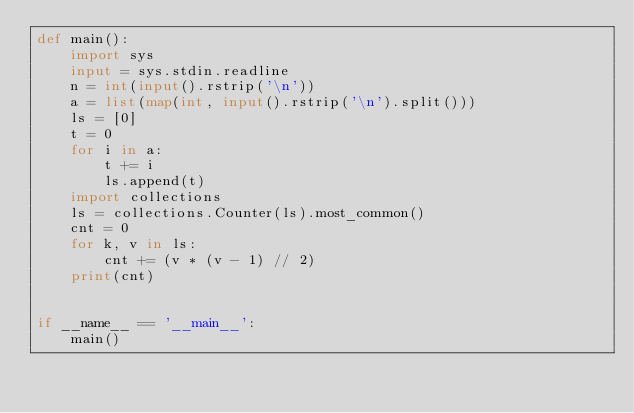<code> <loc_0><loc_0><loc_500><loc_500><_Python_>def main():
    import sys
    input = sys.stdin.readline
    n = int(input().rstrip('\n'))
    a = list(map(int, input().rstrip('\n').split()))
    ls = [0]
    t = 0
    for i in a:
        t += i
        ls.append(t)
    import collections
    ls = collections.Counter(ls).most_common()
    cnt = 0
    for k, v in ls:
        cnt += (v * (v - 1) // 2)
    print(cnt)


if __name__ == '__main__':
    main()
</code> 